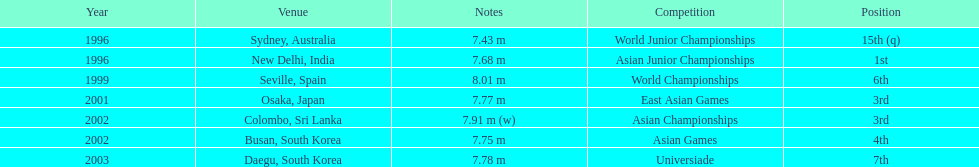What rankings has this competitor placed through the competitions? 15th (q), 1st, 6th, 3rd, 3rd, 4th, 7th. In which competition did the competitor place 1st? Asian Junior Championships. 